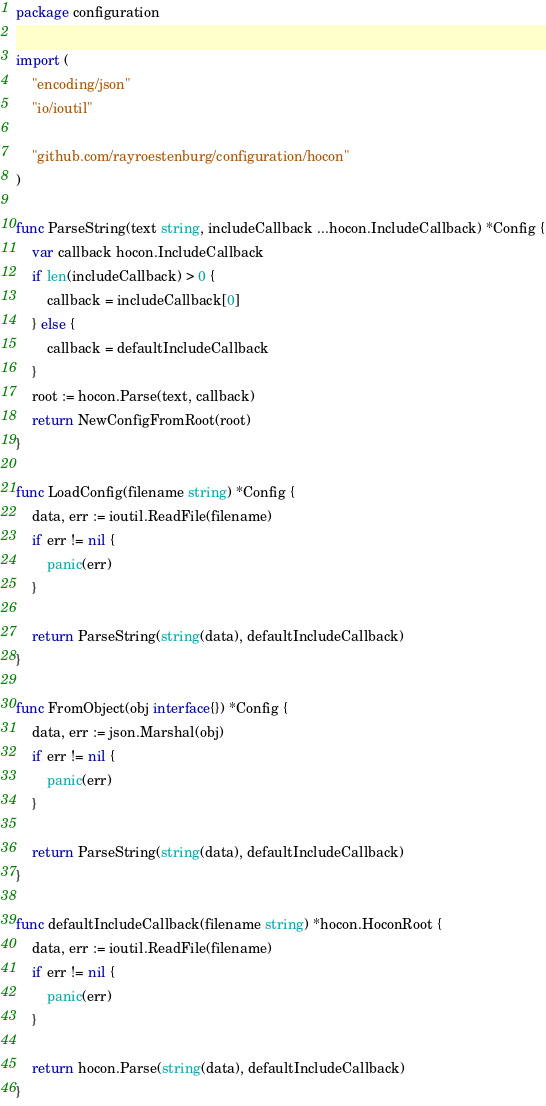Convert code to text. <code><loc_0><loc_0><loc_500><loc_500><_Go_>package configuration

import (
	"encoding/json"
	"io/ioutil"

	"github.com/rayroestenburg/configuration/hocon"
)

func ParseString(text string, includeCallback ...hocon.IncludeCallback) *Config {
	var callback hocon.IncludeCallback
	if len(includeCallback) > 0 {
		callback = includeCallback[0]
	} else {
		callback = defaultIncludeCallback
	}
	root := hocon.Parse(text, callback)
	return NewConfigFromRoot(root)
}

func LoadConfig(filename string) *Config {
	data, err := ioutil.ReadFile(filename)
	if err != nil {
		panic(err)
	}

	return ParseString(string(data), defaultIncludeCallback)
}

func FromObject(obj interface{}) *Config {
	data, err := json.Marshal(obj)
	if err != nil {
		panic(err)
	}

	return ParseString(string(data), defaultIncludeCallback)
}

func defaultIncludeCallback(filename string) *hocon.HoconRoot {
	data, err := ioutil.ReadFile(filename)
	if err != nil {
		panic(err)
	}

	return hocon.Parse(string(data), defaultIncludeCallback)
}
</code> 